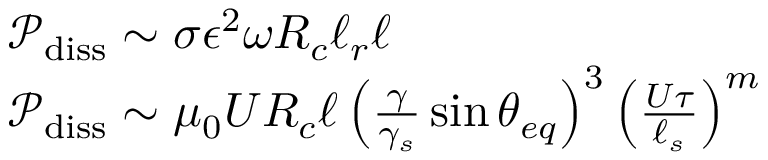<formula> <loc_0><loc_0><loc_500><loc_500>\begin{array} { r l } & { \mathcal { P } _ { d i s s } \sim \sigma \epsilon ^ { 2 } \omega R _ { c } \ell _ { r } \ell } \\ & { \mathcal { P } _ { d i s s } \sim \mu _ { 0 } U R _ { c } \ell \left ( \frac { \gamma } { \gamma _ { s } } \sin { \theta _ { e q } } \right ) ^ { 3 } \left ( \frac { U \tau } { \ell _ { s } } \right ) ^ { m } } \end{array}</formula> 